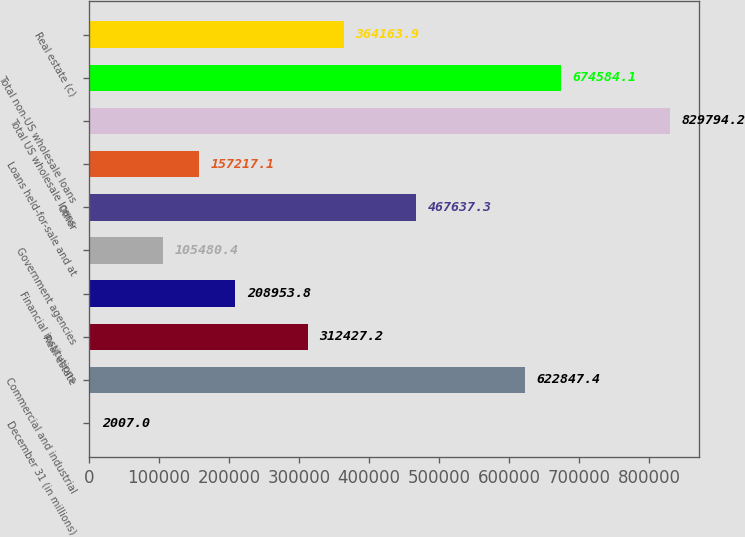Convert chart to OTSL. <chart><loc_0><loc_0><loc_500><loc_500><bar_chart><fcel>December 31 (in millions)<fcel>Commercial and industrial<fcel>Real estate<fcel>Financial institutions<fcel>Government agencies<fcel>Other<fcel>Loans held-for-sale and at<fcel>Total US wholesale loans<fcel>Total non-US wholesale loans<fcel>Real estate (c)<nl><fcel>2007<fcel>622847<fcel>312427<fcel>208954<fcel>105480<fcel>467637<fcel>157217<fcel>829794<fcel>674584<fcel>364164<nl></chart> 